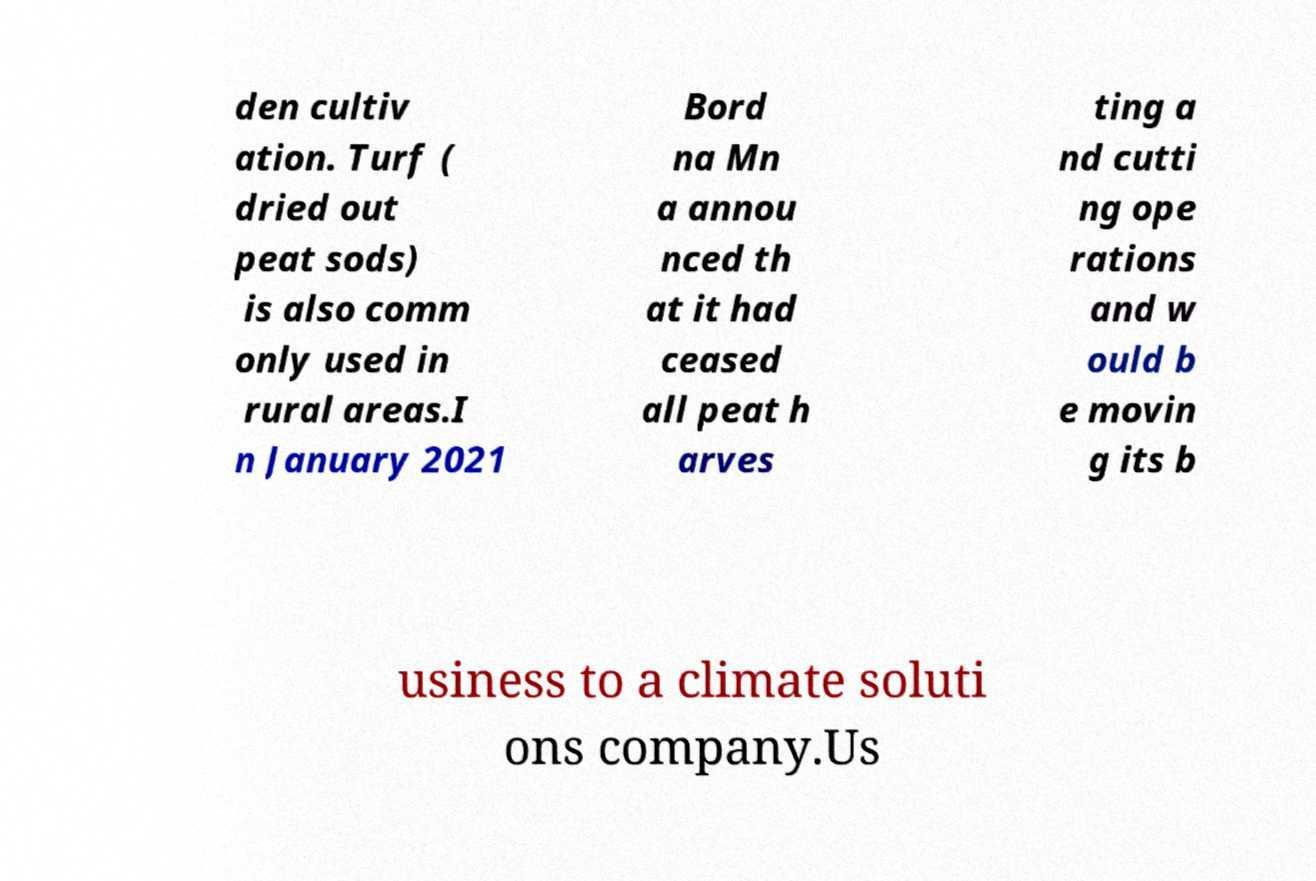Could you extract and type out the text from this image? den cultiv ation. Turf ( dried out peat sods) is also comm only used in rural areas.I n January 2021 Bord na Mn a annou nced th at it had ceased all peat h arves ting a nd cutti ng ope rations and w ould b e movin g its b usiness to a climate soluti ons company.Us 